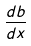<formula> <loc_0><loc_0><loc_500><loc_500>\frac { d b } { d x }</formula> 